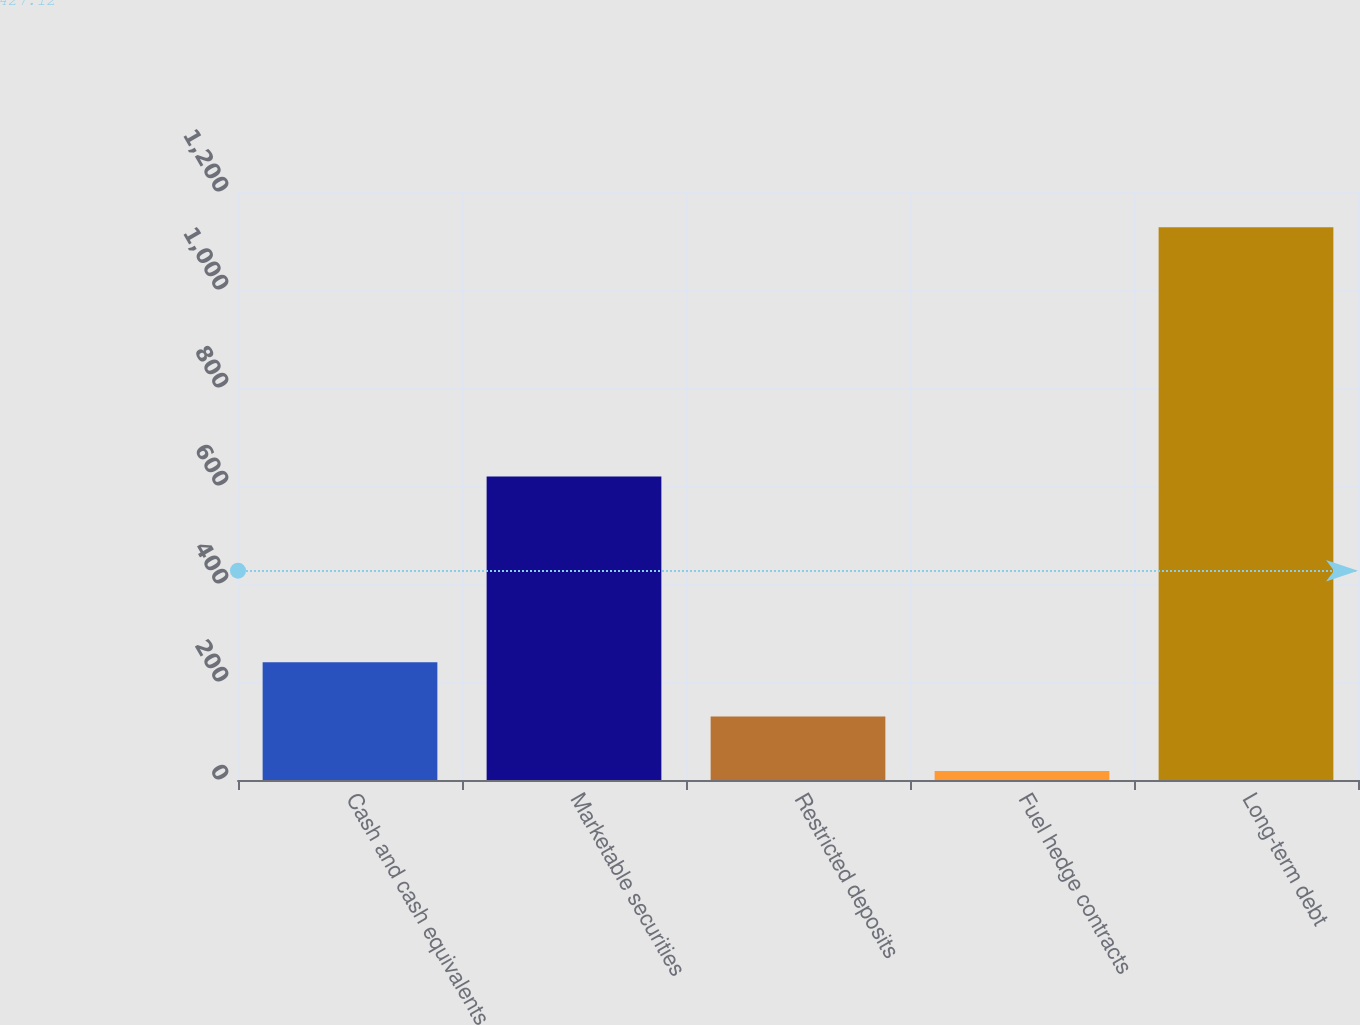Convert chart to OTSL. <chart><loc_0><loc_0><loc_500><loc_500><bar_chart><fcel>Cash and cash equivalents<fcel>Marketable securities<fcel>Restricted deposits<fcel>Fuel hedge contracts<fcel>Long-term debt<nl><fcel>240.34<fcel>619.4<fcel>129.37<fcel>18.4<fcel>1128.1<nl></chart> 